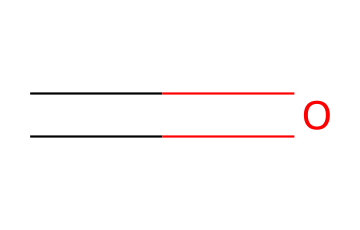What is the chemical name of the compound represented by the SMILES? The SMILES representation shows a carbon (C) connected to an oxygen (O) with a double bond, which identifies the chemical as formaldehyde.
Answer: formaldehyde How many atoms are in this molecule? The structure consists of one carbon atom and one oxygen atom, totaling two atoms.
Answer: 2 What type of bond connects the carbon and oxygen in this molecule? The SMILES indicates a double bond (C=O), which means the bond connecting carbon and oxygen is a double bond.
Answer: double bond How many hydrogen atoms are present in formaldehyde? Formaldehyde, which has the formula CH2O, has two hydrogen atoms bonded to the single bond of carbon.
Answer: 2 Is formaldehyde classified as an organic or inorganic compound? Since formaldehyde contains carbon and is commonly derived from organic materials, it is classified as an organic compound.
Answer: organic What is one common use of formaldehyde? Formaldehyde is commonly used as a preservative and in embalming fluid due to its properties of preventing decay.
Answer: preservative What hazard classification does formaldehyde fall under? Formaldehyde is classified as a hazardous chemical, specifically as a known carcinogen and an irritant.
Answer: carcinogen 